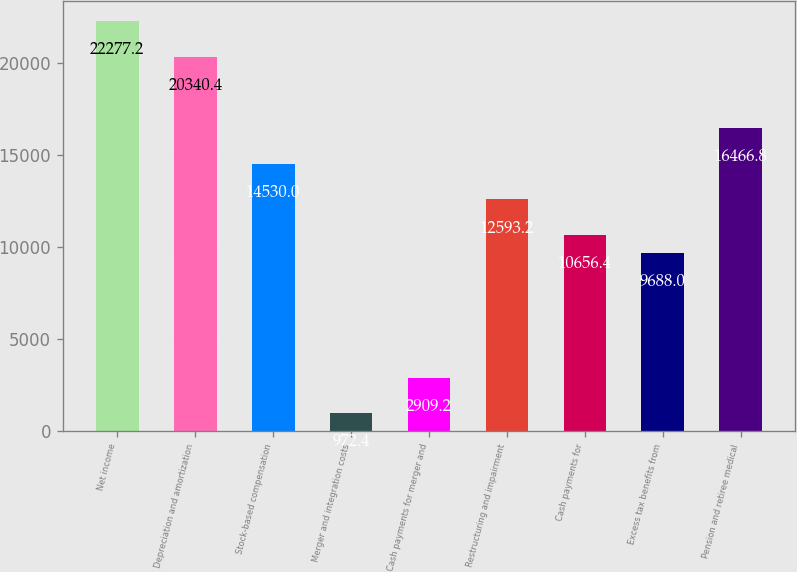<chart> <loc_0><loc_0><loc_500><loc_500><bar_chart><fcel>Net income<fcel>Depreciation and amortization<fcel>Stock-based compensation<fcel>Merger and integration costs<fcel>Cash payments for merger and<fcel>Restructuring and impairment<fcel>Cash payments for<fcel>Excess tax benefits from<fcel>Pension and retiree medical<nl><fcel>22277.2<fcel>20340.4<fcel>14530<fcel>972.4<fcel>2909.2<fcel>12593.2<fcel>10656.4<fcel>9688<fcel>16466.8<nl></chart> 